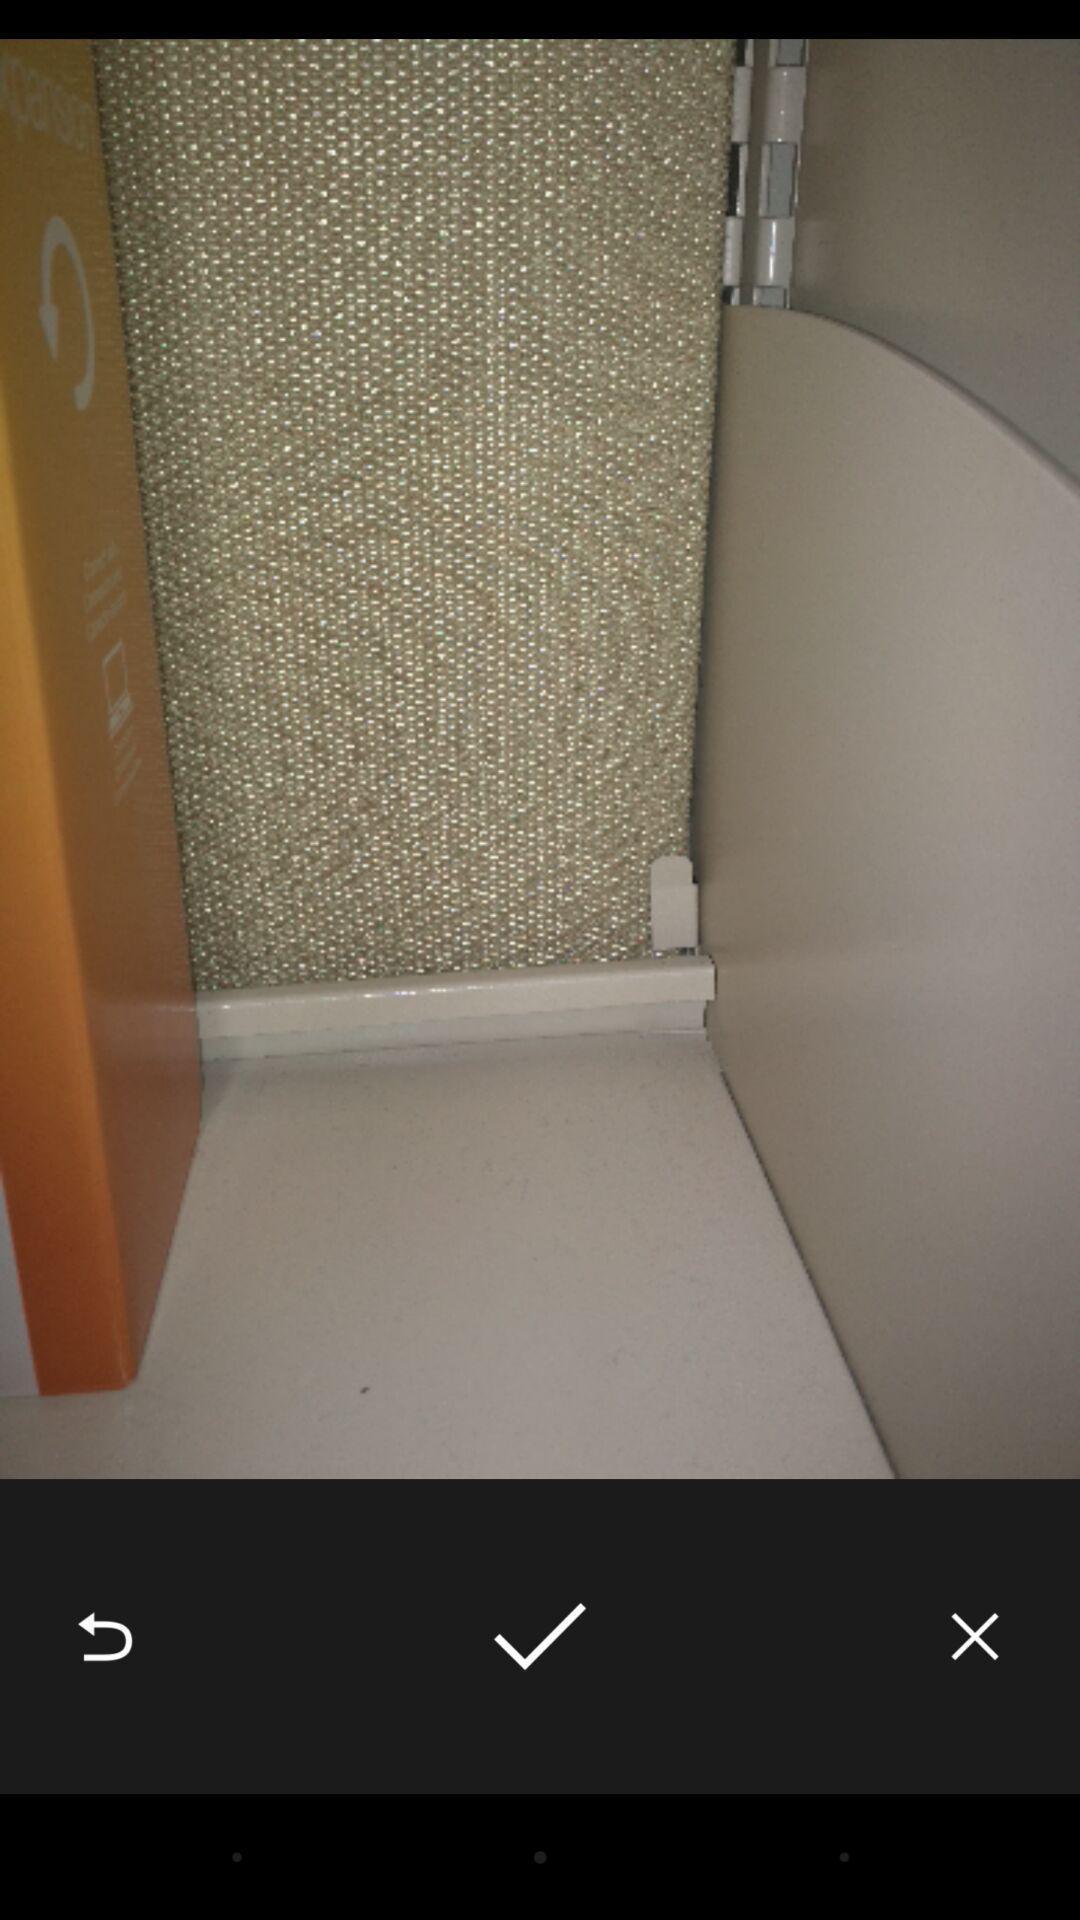What is the overall content of this screenshot? Page showing the image with multiple options. 